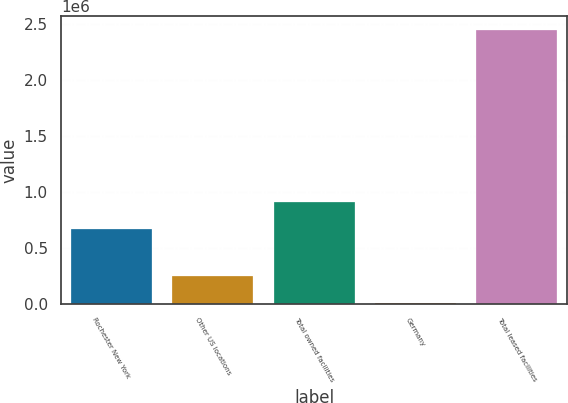<chart> <loc_0><loc_0><loc_500><loc_500><bar_chart><fcel>Rochester New York<fcel>Other US locations<fcel>Total owned facilities<fcel>Germany<fcel>Total leased facilities<nl><fcel>668000<fcel>245500<fcel>912300<fcel>1200<fcel>2.4442e+06<nl></chart> 